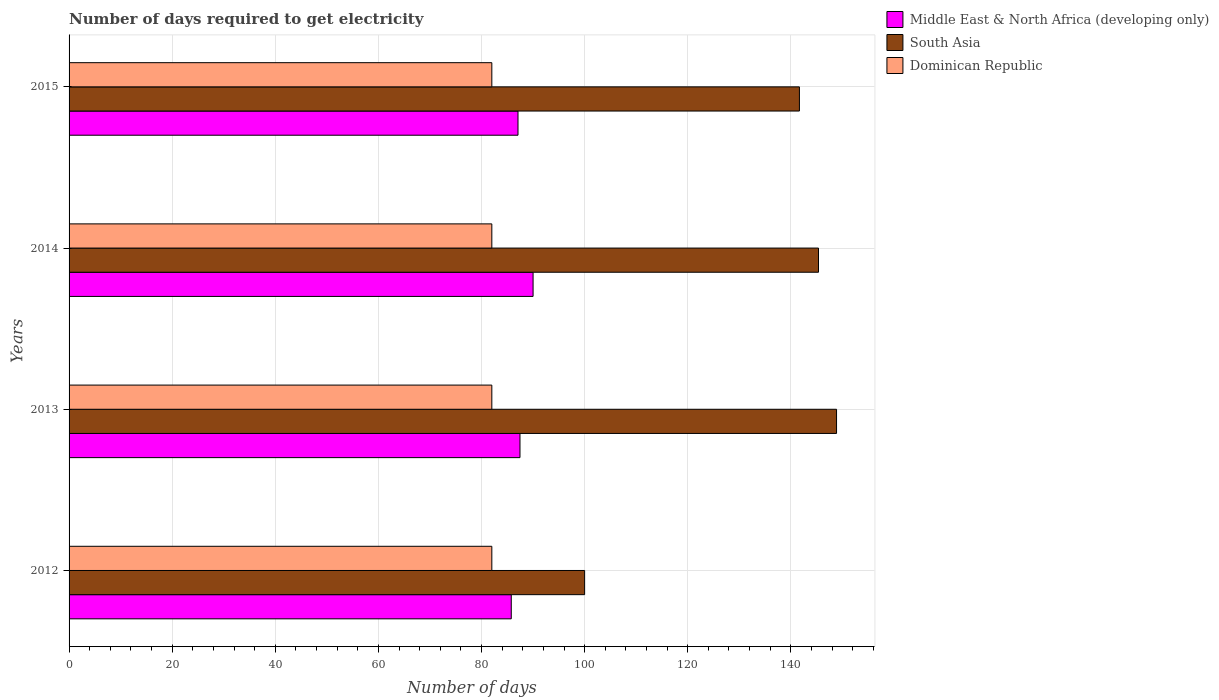Are the number of bars per tick equal to the number of legend labels?
Ensure brevity in your answer.  Yes. Are the number of bars on each tick of the Y-axis equal?
Provide a succinct answer. Yes. In how many cases, is the number of bars for a given year not equal to the number of legend labels?
Offer a very short reply. 0. What is the number of days required to get electricity in in South Asia in 2015?
Make the answer very short. 141.66. Across all years, what is the maximum number of days required to get electricity in in Dominican Republic?
Your response must be concise. 82. In which year was the number of days required to get electricity in in Dominican Republic maximum?
Your answer should be compact. 2012. In which year was the number of days required to get electricity in in South Asia minimum?
Offer a very short reply. 2012. What is the total number of days required to get electricity in in Middle East & North Africa (developing only) in the graph?
Provide a short and direct response. 350.31. What is the difference between the number of days required to get electricity in in South Asia in 2012 and that in 2013?
Ensure brevity in your answer.  -48.86. What is the difference between the number of days required to get electricity in in South Asia in 2014 and the number of days required to get electricity in in Dominican Republic in 2013?
Offer a terse response. 63.36. What is the average number of days required to get electricity in in Middle East & North Africa (developing only) per year?
Provide a succinct answer. 87.58. In the year 2014, what is the difference between the number of days required to get electricity in in South Asia and number of days required to get electricity in in Dominican Republic?
Make the answer very short. 63.36. What is the ratio of the number of days required to get electricity in in Middle East & North Africa (developing only) in 2012 to that in 2015?
Provide a short and direct response. 0.98. Is the number of days required to get electricity in in South Asia in 2012 less than that in 2015?
Offer a very short reply. Yes. What is the difference between the highest and the second highest number of days required to get electricity in in Middle East & North Africa (developing only)?
Offer a terse response. 2.54. What is the difference between the highest and the lowest number of days required to get electricity in in Middle East & North Africa (developing only)?
Ensure brevity in your answer.  4.23. In how many years, is the number of days required to get electricity in in Middle East & North Africa (developing only) greater than the average number of days required to get electricity in in Middle East & North Africa (developing only) taken over all years?
Offer a very short reply. 1. What does the 1st bar from the top in 2015 represents?
Keep it short and to the point. Dominican Republic. What does the 3rd bar from the bottom in 2013 represents?
Ensure brevity in your answer.  Dominican Republic. Is it the case that in every year, the sum of the number of days required to get electricity in in Middle East & North Africa (developing only) and number of days required to get electricity in in Dominican Republic is greater than the number of days required to get electricity in in South Asia?
Your answer should be compact. Yes. How many bars are there?
Ensure brevity in your answer.  12. How many years are there in the graph?
Give a very brief answer. 4. What is the difference between two consecutive major ticks on the X-axis?
Ensure brevity in your answer.  20. Are the values on the major ticks of X-axis written in scientific E-notation?
Make the answer very short. No. Does the graph contain any zero values?
Make the answer very short. No. Does the graph contain grids?
Your response must be concise. Yes. Where does the legend appear in the graph?
Offer a very short reply. Top right. What is the title of the graph?
Your answer should be compact. Number of days required to get electricity. What is the label or title of the X-axis?
Keep it short and to the point. Number of days. What is the Number of days in Middle East & North Africa (developing only) in 2012?
Your response must be concise. 85.77. What is the Number of days of South Asia in 2012?
Make the answer very short. 100. What is the Number of days of Middle East & North Africa (developing only) in 2013?
Make the answer very short. 87.46. What is the Number of days of South Asia in 2013?
Your answer should be compact. 148.86. What is the Number of days in South Asia in 2014?
Offer a terse response. 145.36. What is the Number of days of Dominican Republic in 2014?
Your answer should be compact. 82. What is the Number of days in Middle East & North Africa (developing only) in 2015?
Give a very brief answer. 87.08. What is the Number of days in South Asia in 2015?
Offer a very short reply. 141.66. What is the Number of days of Dominican Republic in 2015?
Your response must be concise. 82. Across all years, what is the maximum Number of days in South Asia?
Offer a terse response. 148.86. Across all years, what is the maximum Number of days in Dominican Republic?
Make the answer very short. 82. Across all years, what is the minimum Number of days of Middle East & North Africa (developing only)?
Your answer should be very brief. 85.77. What is the total Number of days in Middle East & North Africa (developing only) in the graph?
Offer a terse response. 350.31. What is the total Number of days in South Asia in the graph?
Your answer should be compact. 535.89. What is the total Number of days of Dominican Republic in the graph?
Provide a succinct answer. 328. What is the difference between the Number of days in Middle East & North Africa (developing only) in 2012 and that in 2013?
Ensure brevity in your answer.  -1.69. What is the difference between the Number of days of South Asia in 2012 and that in 2013?
Provide a succinct answer. -48.86. What is the difference between the Number of days of Dominican Republic in 2012 and that in 2013?
Your answer should be compact. 0. What is the difference between the Number of days in Middle East & North Africa (developing only) in 2012 and that in 2014?
Your answer should be very brief. -4.23. What is the difference between the Number of days in South Asia in 2012 and that in 2014?
Make the answer very short. -45.36. What is the difference between the Number of days in Dominican Republic in 2012 and that in 2014?
Make the answer very short. 0. What is the difference between the Number of days of Middle East & North Africa (developing only) in 2012 and that in 2015?
Your answer should be compact. -1.31. What is the difference between the Number of days of South Asia in 2012 and that in 2015?
Give a very brief answer. -41.66. What is the difference between the Number of days in Dominican Republic in 2012 and that in 2015?
Your answer should be very brief. 0. What is the difference between the Number of days of Middle East & North Africa (developing only) in 2013 and that in 2014?
Your response must be concise. -2.54. What is the difference between the Number of days in South Asia in 2013 and that in 2014?
Provide a succinct answer. 3.5. What is the difference between the Number of days of Dominican Republic in 2013 and that in 2014?
Provide a short and direct response. 0. What is the difference between the Number of days of Middle East & North Africa (developing only) in 2013 and that in 2015?
Your response must be concise. 0.38. What is the difference between the Number of days of South Asia in 2013 and that in 2015?
Offer a very short reply. 7.2. What is the difference between the Number of days in Dominican Republic in 2013 and that in 2015?
Your response must be concise. 0. What is the difference between the Number of days in Middle East & North Africa (developing only) in 2014 and that in 2015?
Make the answer very short. 2.92. What is the difference between the Number of days in South Asia in 2014 and that in 2015?
Ensure brevity in your answer.  3.7. What is the difference between the Number of days of Middle East & North Africa (developing only) in 2012 and the Number of days of South Asia in 2013?
Your response must be concise. -63.09. What is the difference between the Number of days in Middle East & North Africa (developing only) in 2012 and the Number of days in Dominican Republic in 2013?
Ensure brevity in your answer.  3.77. What is the difference between the Number of days of South Asia in 2012 and the Number of days of Dominican Republic in 2013?
Give a very brief answer. 18. What is the difference between the Number of days of Middle East & North Africa (developing only) in 2012 and the Number of days of South Asia in 2014?
Your answer should be compact. -59.59. What is the difference between the Number of days of Middle East & North Africa (developing only) in 2012 and the Number of days of Dominican Republic in 2014?
Your answer should be compact. 3.77. What is the difference between the Number of days in South Asia in 2012 and the Number of days in Dominican Republic in 2014?
Make the answer very short. 18. What is the difference between the Number of days of Middle East & North Africa (developing only) in 2012 and the Number of days of South Asia in 2015?
Your answer should be very brief. -55.89. What is the difference between the Number of days in Middle East & North Africa (developing only) in 2012 and the Number of days in Dominican Republic in 2015?
Offer a very short reply. 3.77. What is the difference between the Number of days of South Asia in 2012 and the Number of days of Dominican Republic in 2015?
Offer a terse response. 18. What is the difference between the Number of days of Middle East & North Africa (developing only) in 2013 and the Number of days of South Asia in 2014?
Offer a very short reply. -57.9. What is the difference between the Number of days of Middle East & North Africa (developing only) in 2013 and the Number of days of Dominican Republic in 2014?
Provide a succinct answer. 5.46. What is the difference between the Number of days of South Asia in 2013 and the Number of days of Dominican Republic in 2014?
Your answer should be compact. 66.86. What is the difference between the Number of days in Middle East & North Africa (developing only) in 2013 and the Number of days in South Asia in 2015?
Provide a succinct answer. -54.2. What is the difference between the Number of days in Middle East & North Africa (developing only) in 2013 and the Number of days in Dominican Republic in 2015?
Ensure brevity in your answer.  5.46. What is the difference between the Number of days in South Asia in 2013 and the Number of days in Dominican Republic in 2015?
Give a very brief answer. 66.86. What is the difference between the Number of days of Middle East & North Africa (developing only) in 2014 and the Number of days of South Asia in 2015?
Make the answer very short. -51.66. What is the difference between the Number of days of Middle East & North Africa (developing only) in 2014 and the Number of days of Dominican Republic in 2015?
Offer a very short reply. 8. What is the difference between the Number of days of South Asia in 2014 and the Number of days of Dominican Republic in 2015?
Offer a terse response. 63.36. What is the average Number of days of Middle East & North Africa (developing only) per year?
Provide a short and direct response. 87.58. What is the average Number of days in South Asia per year?
Ensure brevity in your answer.  133.97. In the year 2012, what is the difference between the Number of days of Middle East & North Africa (developing only) and Number of days of South Asia?
Provide a succinct answer. -14.23. In the year 2012, what is the difference between the Number of days of Middle East & North Africa (developing only) and Number of days of Dominican Republic?
Your answer should be compact. 3.77. In the year 2013, what is the difference between the Number of days in Middle East & North Africa (developing only) and Number of days in South Asia?
Provide a short and direct response. -61.4. In the year 2013, what is the difference between the Number of days in Middle East & North Africa (developing only) and Number of days in Dominican Republic?
Provide a succinct answer. 5.46. In the year 2013, what is the difference between the Number of days in South Asia and Number of days in Dominican Republic?
Offer a very short reply. 66.86. In the year 2014, what is the difference between the Number of days in Middle East & North Africa (developing only) and Number of days in South Asia?
Give a very brief answer. -55.36. In the year 2014, what is the difference between the Number of days of South Asia and Number of days of Dominican Republic?
Offer a very short reply. 63.36. In the year 2015, what is the difference between the Number of days in Middle East & North Africa (developing only) and Number of days in South Asia?
Ensure brevity in your answer.  -54.59. In the year 2015, what is the difference between the Number of days of Middle East & North Africa (developing only) and Number of days of Dominican Republic?
Make the answer very short. 5.08. In the year 2015, what is the difference between the Number of days in South Asia and Number of days in Dominican Republic?
Give a very brief answer. 59.66. What is the ratio of the Number of days in Middle East & North Africa (developing only) in 2012 to that in 2013?
Provide a short and direct response. 0.98. What is the ratio of the Number of days in South Asia in 2012 to that in 2013?
Ensure brevity in your answer.  0.67. What is the ratio of the Number of days of Dominican Republic in 2012 to that in 2013?
Offer a terse response. 1. What is the ratio of the Number of days in Middle East & North Africa (developing only) in 2012 to that in 2014?
Offer a terse response. 0.95. What is the ratio of the Number of days of South Asia in 2012 to that in 2014?
Provide a succinct answer. 0.69. What is the ratio of the Number of days of Dominican Republic in 2012 to that in 2014?
Provide a short and direct response. 1. What is the ratio of the Number of days in Middle East & North Africa (developing only) in 2012 to that in 2015?
Offer a very short reply. 0.98. What is the ratio of the Number of days in South Asia in 2012 to that in 2015?
Provide a short and direct response. 0.71. What is the ratio of the Number of days of Middle East & North Africa (developing only) in 2013 to that in 2014?
Your answer should be compact. 0.97. What is the ratio of the Number of days in South Asia in 2013 to that in 2014?
Offer a terse response. 1.02. What is the ratio of the Number of days in Dominican Republic in 2013 to that in 2014?
Keep it short and to the point. 1. What is the ratio of the Number of days in South Asia in 2013 to that in 2015?
Provide a short and direct response. 1.05. What is the ratio of the Number of days of Dominican Republic in 2013 to that in 2015?
Your response must be concise. 1. What is the ratio of the Number of days in Middle East & North Africa (developing only) in 2014 to that in 2015?
Offer a very short reply. 1.03. What is the ratio of the Number of days in South Asia in 2014 to that in 2015?
Provide a short and direct response. 1.03. What is the ratio of the Number of days of Dominican Republic in 2014 to that in 2015?
Your answer should be compact. 1. What is the difference between the highest and the second highest Number of days in Middle East & North Africa (developing only)?
Give a very brief answer. 2.54. What is the difference between the highest and the second highest Number of days in South Asia?
Make the answer very short. 3.5. What is the difference between the highest and the lowest Number of days of Middle East & North Africa (developing only)?
Make the answer very short. 4.23. What is the difference between the highest and the lowest Number of days of South Asia?
Offer a very short reply. 48.86. What is the difference between the highest and the lowest Number of days of Dominican Republic?
Offer a terse response. 0. 